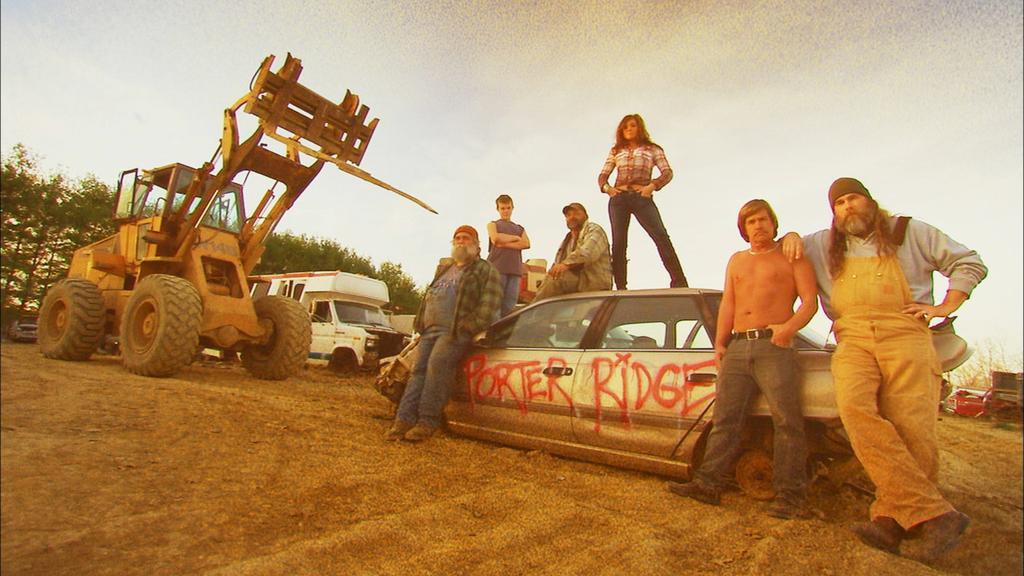Please provide a concise description of this image. In this image there are a few people standing on the surface and on the car, on the car there is some text written, around them there are trucks and cars, in the background of the image there are trees. 